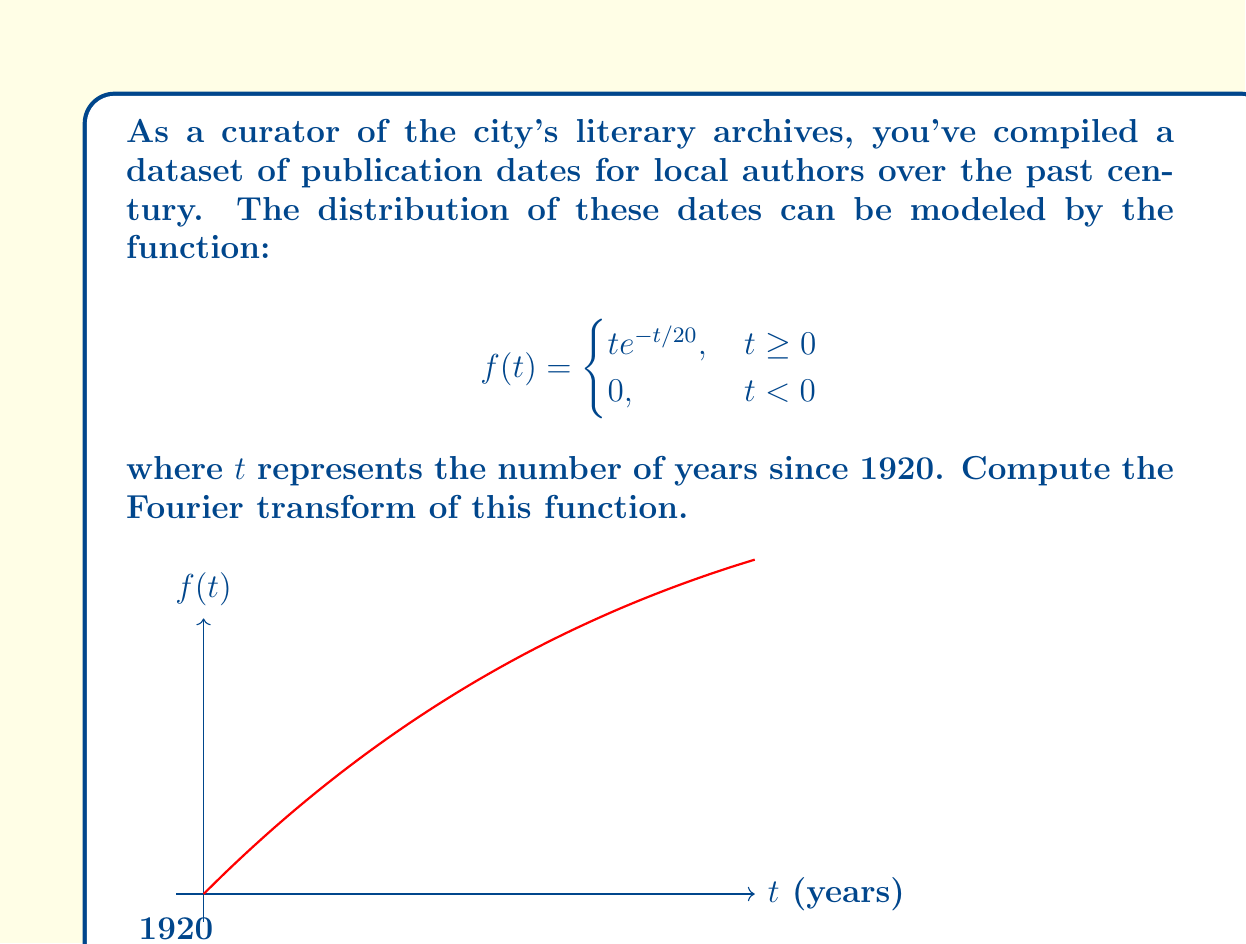Can you answer this question? To compute the Fourier transform of $f(t)$, we use the definition:

$$F(\omega) = \int_{-\infty}^{\infty} f(t)e^{-i\omega t} dt$$

Given the piecewise nature of our function, we can simplify this to:

$$F(\omega) = \int_{0}^{\infty} te^{-t/20}e^{-i\omega t} dt$$

Let's solve this integral step by step:

1) First, let's combine the exponential terms:
   $$F(\omega) = \int_{0}^{\infty} te^{-t(1/20+i\omega)} dt$$

2) Let $a = 1/20 + i\omega$. Then our integral becomes:
   $$F(\omega) = \int_{0}^{\infty} te^{-at} dt$$

3) We can solve this using integration by parts. Let $u = t$ and $dv = e^{-at}dt$. Then $du = dt$ and $v = -\frac{1}{a}e^{-at}$. Applying the formula:

   $$F(\omega) = \left[-\frac{t}{a}e^{-at}\right]_{0}^{\infty} + \frac{1}{a}\int_{0}^{\infty} e^{-at} dt$$

4) The first term evaluates to zero at both limits. For the second term:
   $$F(\omega) = \frac{1}{a}\left[-\frac{1}{a}e^{-at}\right]_{0}^{\infty} = \frac{1}{a^2}$$

5) Substituting back $a = 1/20 + i\omega$:
   $$F(\omega) = \frac{1}{(1/20 + i\omega)^2}$$

6) To simplify, multiply numerator and denominator by the complex conjugate:
   $$F(\omega) = \frac{(1/20 - i\omega)^2}{((1/20)^2 + \omega^2)^2}$$

7) Expanding the numerator:
   $$F(\omega) = \frac{1/400 - i\omega/10 - \omega^2}{((1/20)^2 + \omega^2)^2}$$

This is the Fourier transform of our original function.
Answer: $$F(\omega) = \frac{1/400 - i\omega/10 - \omega^2}{((1/20)^2 + \omega^2)^2}$$ 